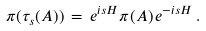Convert formula to latex. <formula><loc_0><loc_0><loc_500><loc_500>\pi ( \tau _ { s } ( A ) ) \, = \, e ^ { i s H } \pi ( A ) \, e ^ { - i s H } \, .</formula> 